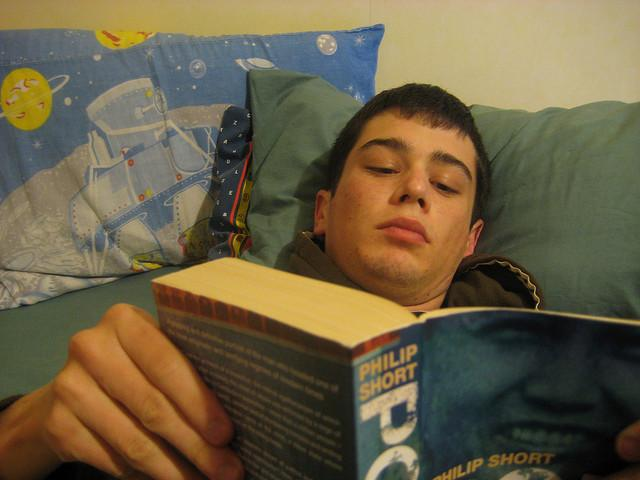What is the boy doing with the book? reading 